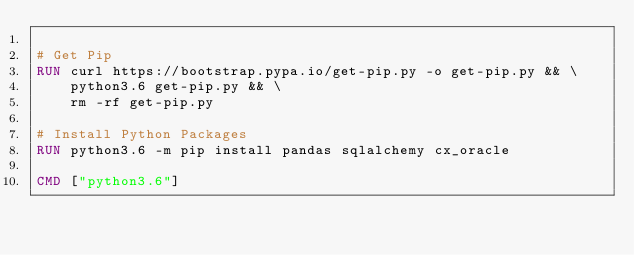Convert code to text. <code><loc_0><loc_0><loc_500><loc_500><_Dockerfile_>
# Get Pip
RUN curl https://bootstrap.pypa.io/get-pip.py -o get-pip.py && \
    python3.6 get-pip.py && \
    rm -rf get-pip.py

# Install Python Packages
RUN python3.6 -m pip install pandas sqlalchemy cx_oracle

CMD ["python3.6"]
</code> 